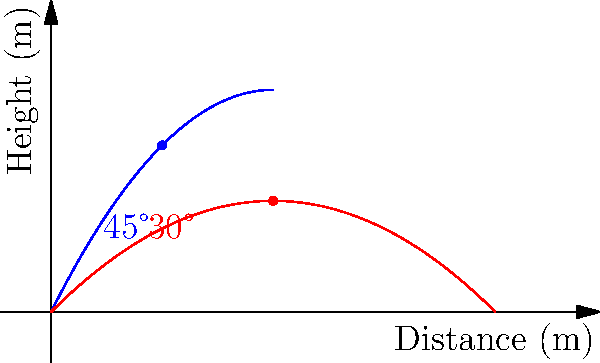As a Carcassonne enthusiast who also commentates on sports, you're analyzing the trajectory of soccer balls kicked at different angles. The graph shows two parabolic paths: one for a ball kicked at a 45° angle (blue) and another at a 30° angle (red). Both balls are kicked with the same initial velocity. At what distance from the kick point does the 30° kick (red path) reach the same height as the 45° kick (blue path) at the 5-meter mark? Let's approach this step-by-step:

1) First, we need to find the height of the 45° kick (blue path) at the 5-meter mark.
   The equation for this path is approximately $y = -0.1x^2 + 2x$.
   At $x = 5$, $y = -0.1(5^2) + 2(5) = -2.5 + 10 = 7.5$ meters.

2) Now, we need to find where the 30° kick (red path) reaches this same height.
   The equation for this path is approximately $y = -0.05x^2 + x$.

3) We can set up an equation:
   $7.5 = -0.05x^2 + x$

4) Rearranging the equation:
   $0.05x^2 - x + 7.5 = 0$

5) This is a quadratic equation. We can solve it using the quadratic formula:
   $x = \frac{-b \pm \sqrt{b^2 - 4ac}}{2a}$

   Where $a = 0.05$, $b = -1$, and $c = 7.5$

6) Plugging in these values:
   $x = \frac{1 \pm \sqrt{1 - 4(0.05)(7.5)}}{2(0.05)}$
   $= \frac{1 \pm \sqrt{1 - 1.5}}{0.1}$
   $= \frac{1 \pm \sqrt{-0.5}}{0.1}$

7) Since we can't have a negative value under the square root for a real solution, we only consider the positive root:
   $x = \frac{1 + \sqrt{0.5}}{0.1} \approx 10$ meters

Therefore, the 30° kick reaches the same height as the 45° kick at 5 meters when it's approximately 10 meters from the kick point.
Answer: 10 meters 